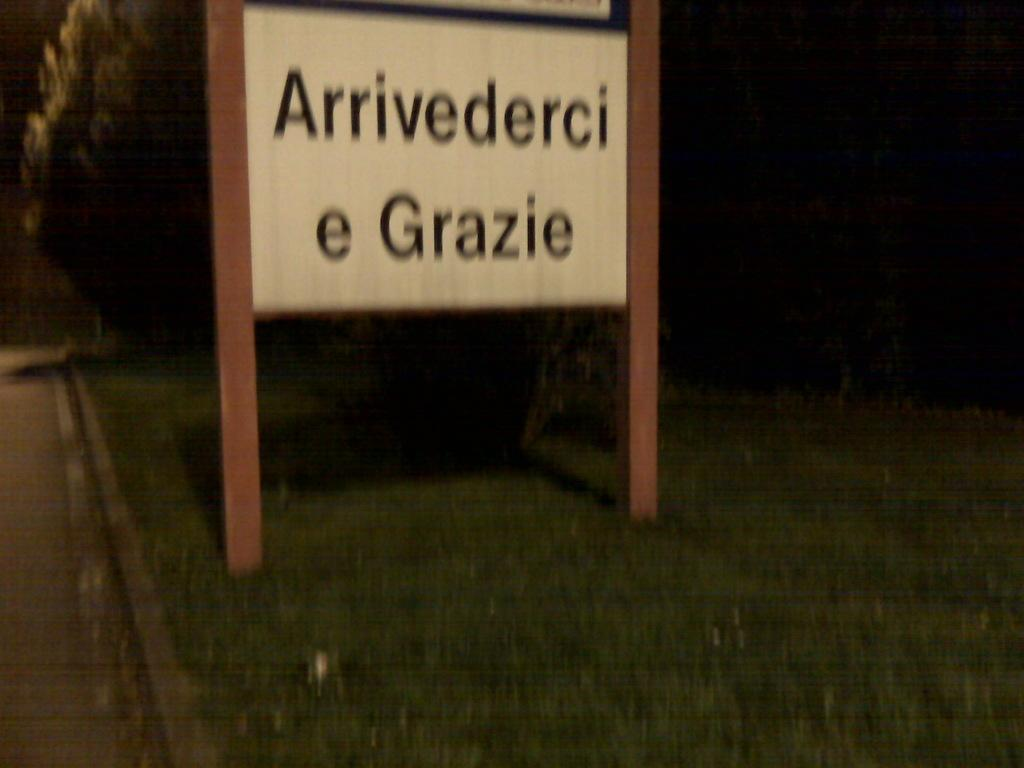What structure is attached to poles in the image? There is a board attached to poles in the image. What type of vegetation is present in the image? There is grass in the image. What natural element can be seen in the image? There is a tree in the image. What man-made feature is visible in the image? There is a road in the image. How would you describe the lighting in the image? The background of the image is dark. How many cakes are being whipped in the image? There are no cakes or whipping activity present in the image. 